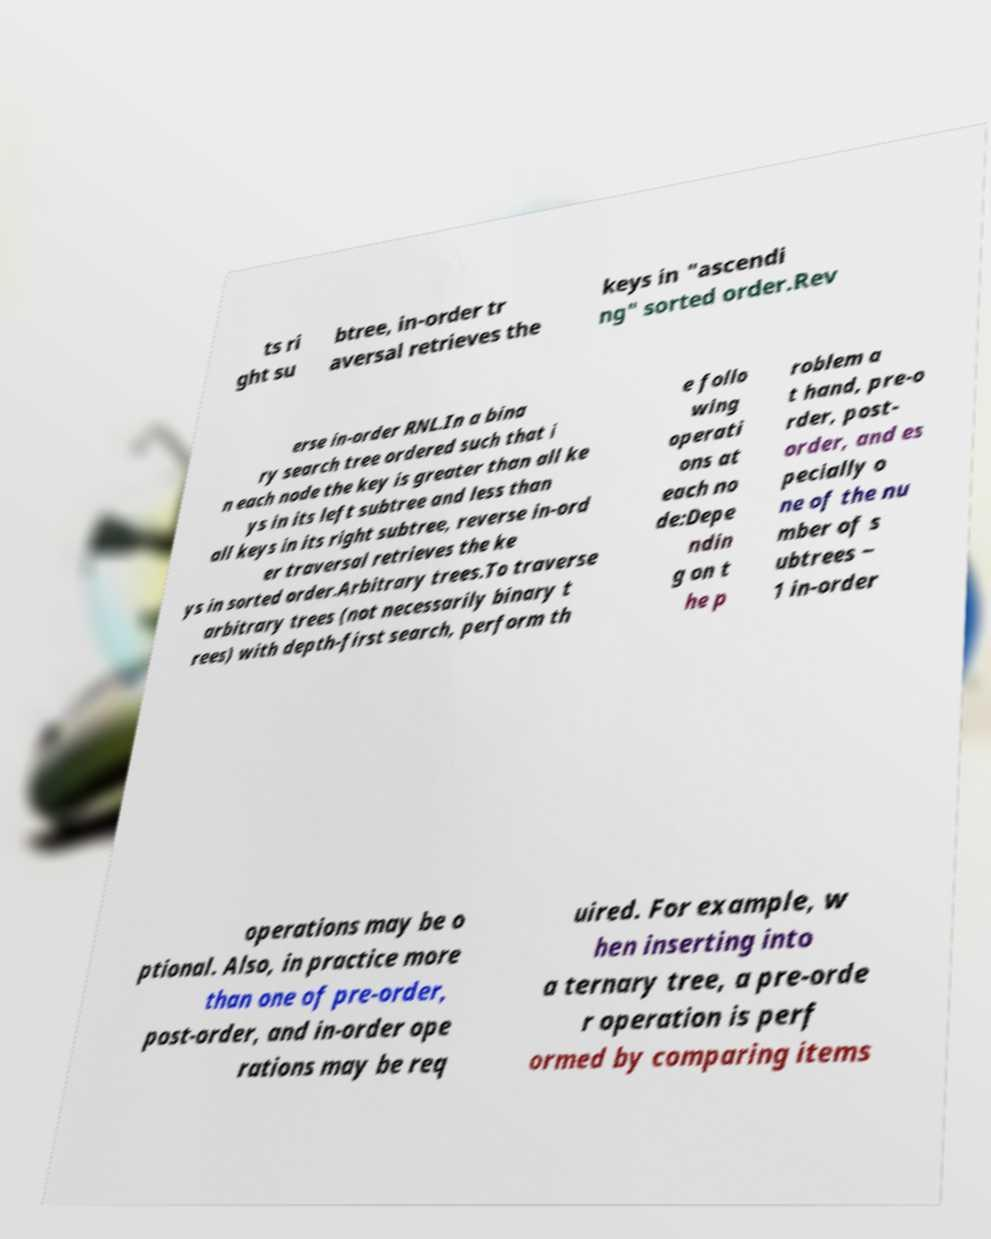Please read and relay the text visible in this image. What does it say? ts ri ght su btree, in-order tr aversal retrieves the keys in "ascendi ng" sorted order.Rev erse in-order RNL.In a bina ry search tree ordered such that i n each node the key is greater than all ke ys in its left subtree and less than all keys in its right subtree, reverse in-ord er traversal retrieves the ke ys in sorted order.Arbitrary trees.To traverse arbitrary trees (not necessarily binary t rees) with depth-first search, perform th e follo wing operati ons at each no de:Depe ndin g on t he p roblem a t hand, pre-o rder, post- order, and es pecially o ne of the nu mber of s ubtrees − 1 in-order operations may be o ptional. Also, in practice more than one of pre-order, post-order, and in-order ope rations may be req uired. For example, w hen inserting into a ternary tree, a pre-orde r operation is perf ormed by comparing items 